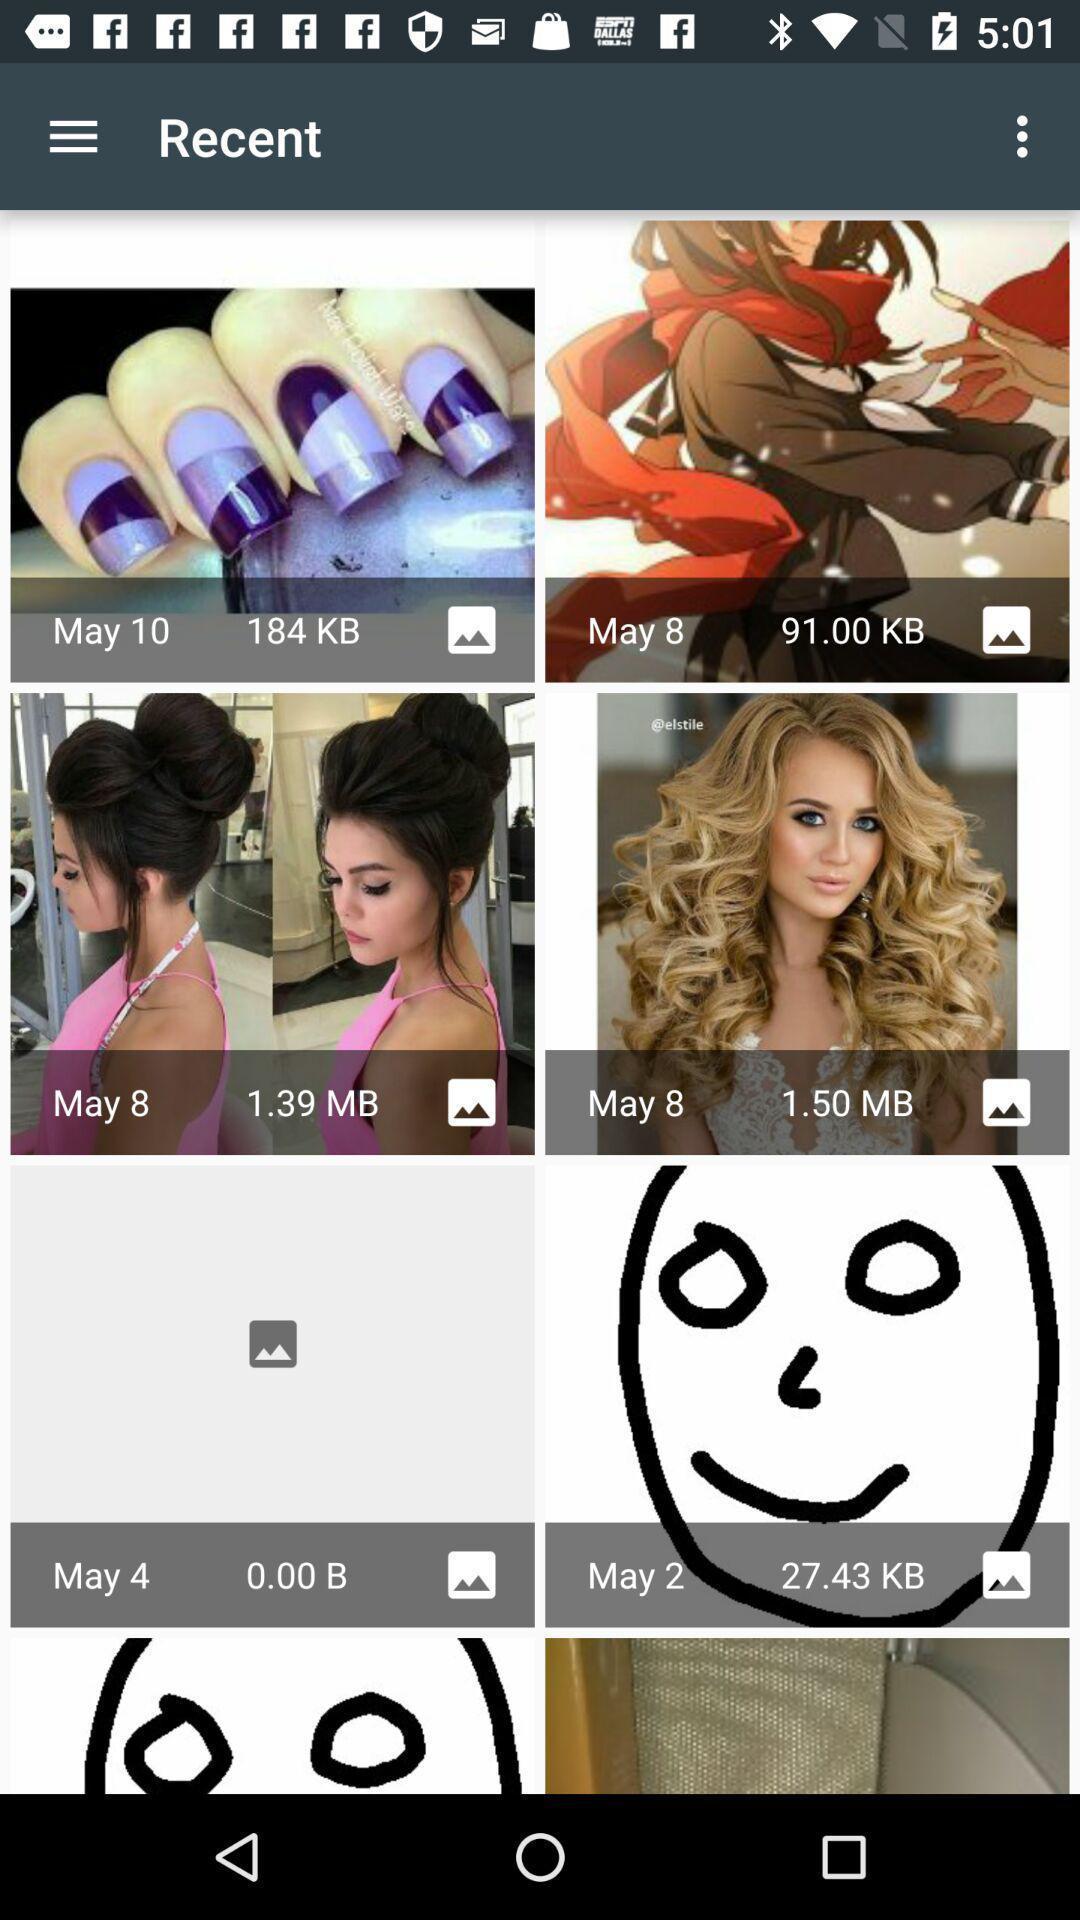Tell me what you see in this picture. Screen showing images. 